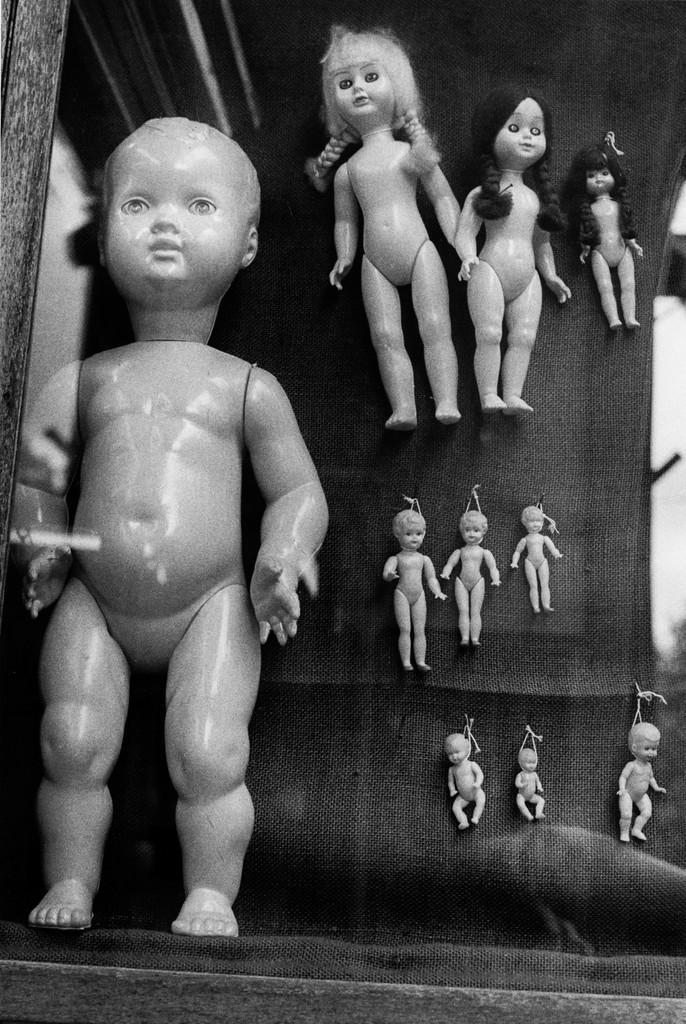Describe this image in one or two sentences. In this image we can see group of dolls placed in a glass cupboard in the background we can see three dolls having hair. Two dolls are having black hair and one doll is having white hair. 